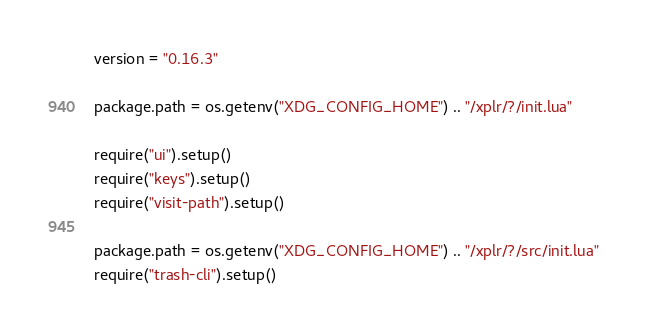<code> <loc_0><loc_0><loc_500><loc_500><_Lua_>version = "0.16.3"

package.path = os.getenv("XDG_CONFIG_HOME") .. "/xplr/?/init.lua"

require("ui").setup()
require("keys").setup()
require("visit-path").setup()

package.path = os.getenv("XDG_CONFIG_HOME") .. "/xplr/?/src/init.lua"
require("trash-cli").setup()
</code> 